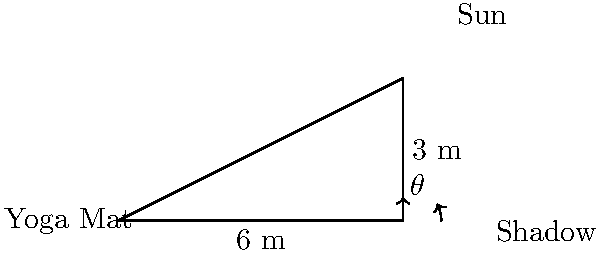During an outdoor yoga session, you notice that your 6-meter yoga mat casts a 3-meter shadow. Using this information, calculate the angle of elevation of the sun. Round your answer to the nearest degree. To solve this problem, we'll use trigonometry, specifically the tangent function. Let's approach this step-by-step:

1) In the right triangle formed by the yoga mat, its shadow, and the sun's rays, we have:
   - The adjacent side (shadow length) = 6 meters
   - The opposite side (yoga mat height) = 3 meters
   - The angle we're looking for is the one between the ground and the sun's rays

2) The tangent of an angle in a right triangle is defined as the ratio of the opposite side to the adjacent side:

   $\tan(\theta) = \frac{\text{opposite}}{\text{adjacent}} = \frac{\text{yoga mat height}}{\text{shadow length}}$

3) Plugging in our values:

   $\tan(\theta) = \frac{3}{6} = \frac{1}{2} = 0.5$

4) To find the angle $\theta$, we need to use the inverse tangent (arctangent) function:

   $\theta = \arctan(0.5)$

5) Using a calculator or trigonometric tables:

   $\theta \approx 26.57°$

6) Rounding to the nearest degree:

   $\theta \approx 27°$

Therefore, the angle of elevation of the sun is approximately 27 degrees.
Answer: $27°$ 